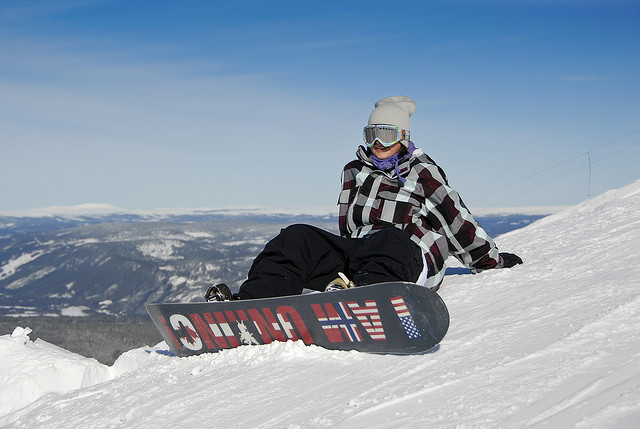Read and extract the text from this image. UNXINC AM I 